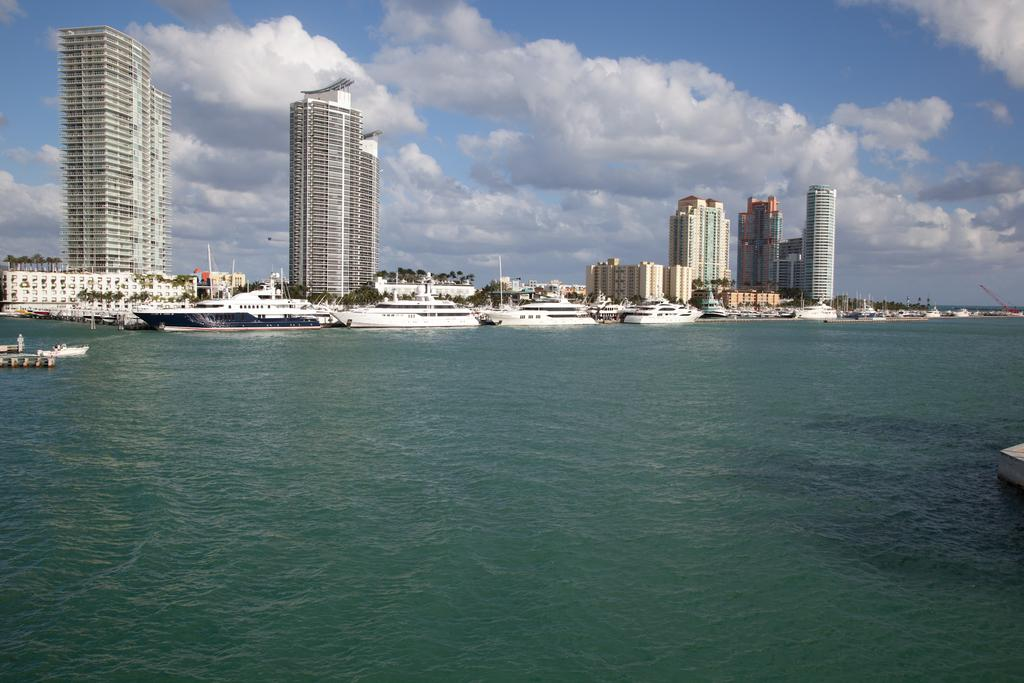What is in the front of the image? There is water in the front of the image. What can be seen on the water in the background? There are boats on the water in the background. What type of vegetation is visible in the background? There are trees in the background. What type of structures can be seen in the background? There are buildings in the background. What is visible in the sky in the background? There are clouds visible in the background, and the sky is also visible. Where is the doll located in the image? There is no doll present in the image. How many sheep are visible in the image? There are no sheep present in the image. 